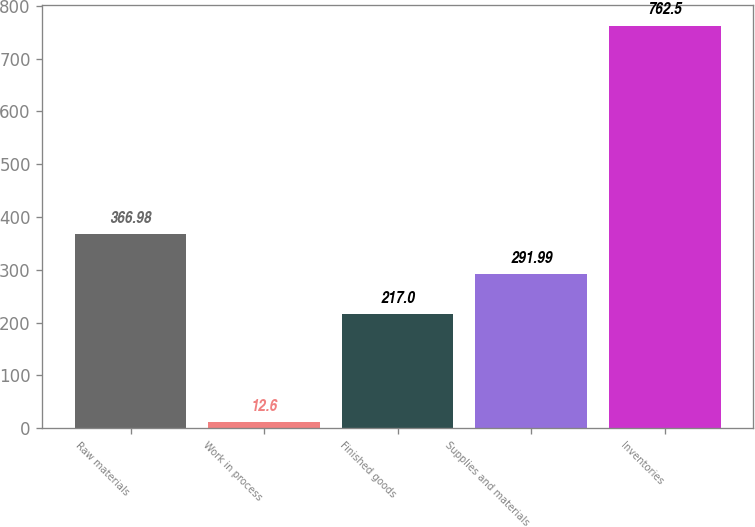Convert chart to OTSL. <chart><loc_0><loc_0><loc_500><loc_500><bar_chart><fcel>Raw materials<fcel>Work in process<fcel>Finished goods<fcel>Supplies and materials<fcel>Inventories<nl><fcel>366.98<fcel>12.6<fcel>217<fcel>291.99<fcel>762.5<nl></chart> 